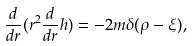<formula> <loc_0><loc_0><loc_500><loc_500>\frac { d } { d r } ( r ^ { 2 } \frac { d } { d r } h ) = - 2 m \delta ( \rho - \xi ) ,</formula> 